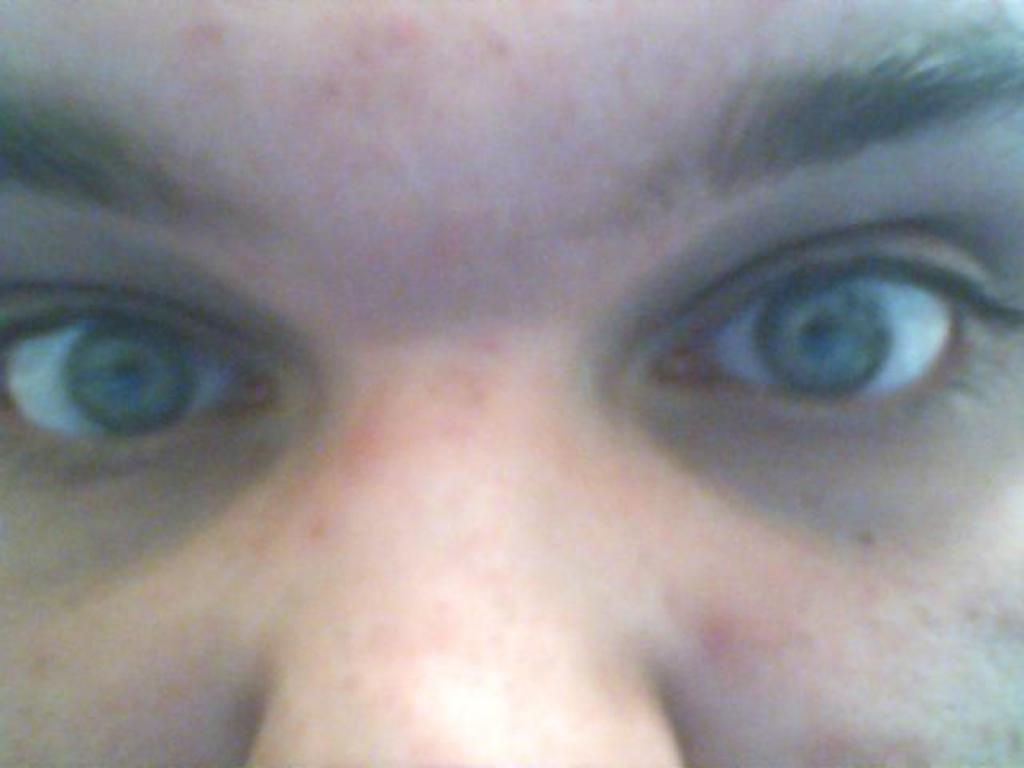What is the main subject of the image? The main subject of the image is the face of a person. What facial features can be seen on the face? The face has eyes and a nose. What type of shoes is the person wearing in the image? There is no shoes visible in the image, as the main subject is the face of a person. 